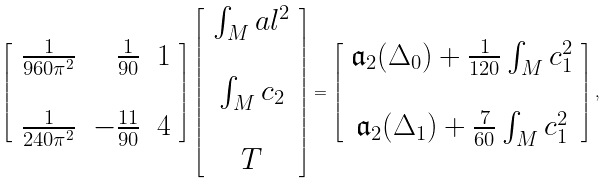<formula> <loc_0><loc_0><loc_500><loc_500>\left [ \begin{array} { r r r } \frac { 1 } { 9 6 0 \pi ^ { 2 } } & \frac { 1 } { 9 0 } & 1 \\ & & \\ \frac { 1 } { 2 4 0 \pi ^ { 2 } } & - \frac { 1 1 } { 9 0 } & 4 \end{array} \right ] \left [ \begin{array} { c } \int _ { M } a l ^ { 2 } \\ \\ \int _ { M } c _ { 2 } \\ \\ T \end{array} \right ] = \left [ \begin{array} { c } \mathfrak { a } _ { 2 } ( \Delta _ { 0 } ) + \frac { 1 } { 1 2 0 } \int _ { M } c _ { 1 } ^ { 2 } \\ \\ \mathfrak { a } _ { 2 } ( \Delta _ { 1 } ) + \frac { 7 } { 6 0 } \int _ { M } c _ { 1 } ^ { 2 } \end{array} \right ] ,</formula> 